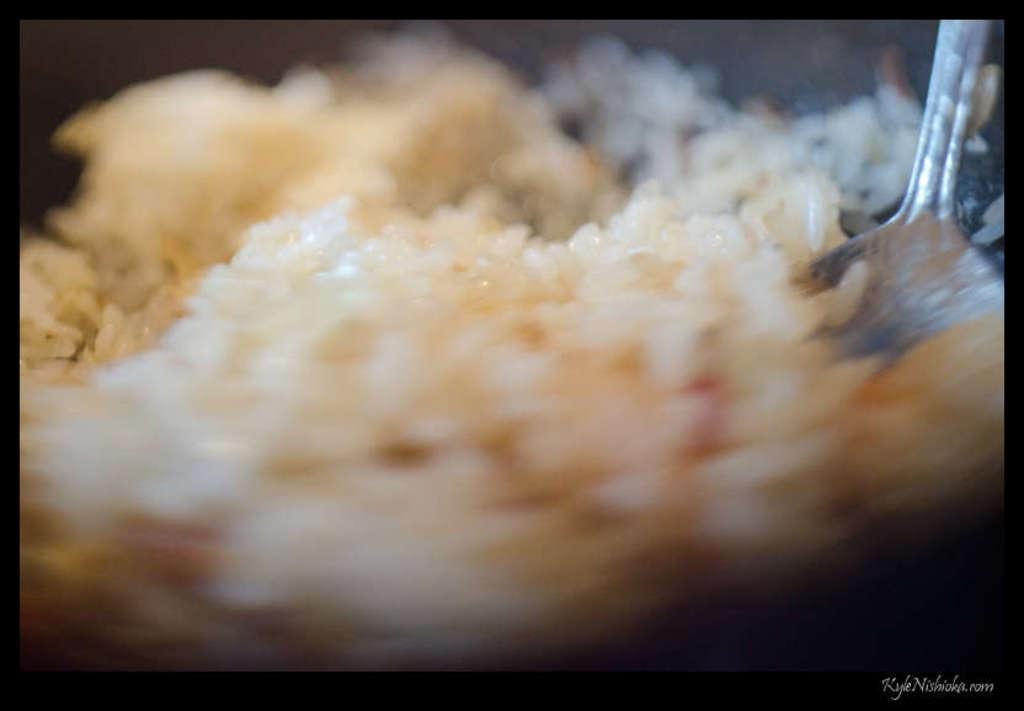What can be seen in the image related to eating? There is food and a spoon in the image. What might be used to consume the food in the image? The spoon in the image can be used to consume the food. Where is the nearest library to the location of the image? There is no information about the location of the image, so it is impossible to determine the nearest library. 